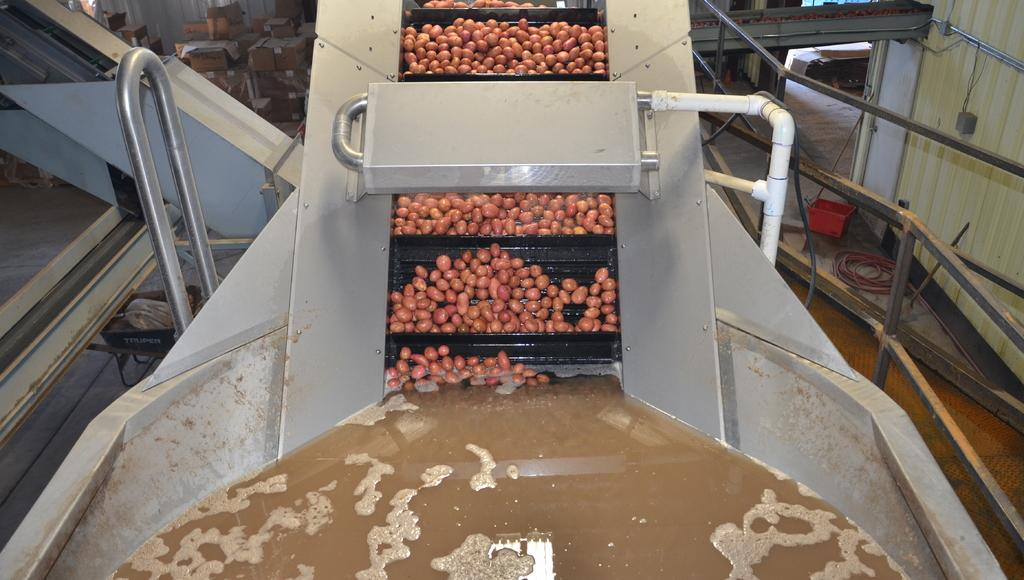What is being processed in the machine in the image? There are potatoes in the processing machine. What type of infrastructure is visible in the image? Pipelines are visible in the image. What type of packaging is present in the image? Cardboard cartons and plastic containers are visible in the image. What type of transportation is present in the image? A trolley is in the image. What type of structure is visible in the image? There are walls in the image. Can you see any ants carrying pieces of stew in the image? No, there are no ants or stew present in the image. 